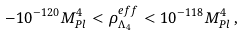<formula> <loc_0><loc_0><loc_500><loc_500>- 1 0 ^ { - 1 2 0 } M _ { P l } ^ { 4 } < \rho ^ { e f f } _ { \Lambda _ { 4 } } < 1 0 ^ { - 1 1 8 } M _ { P l } ^ { 4 } \, ,</formula> 